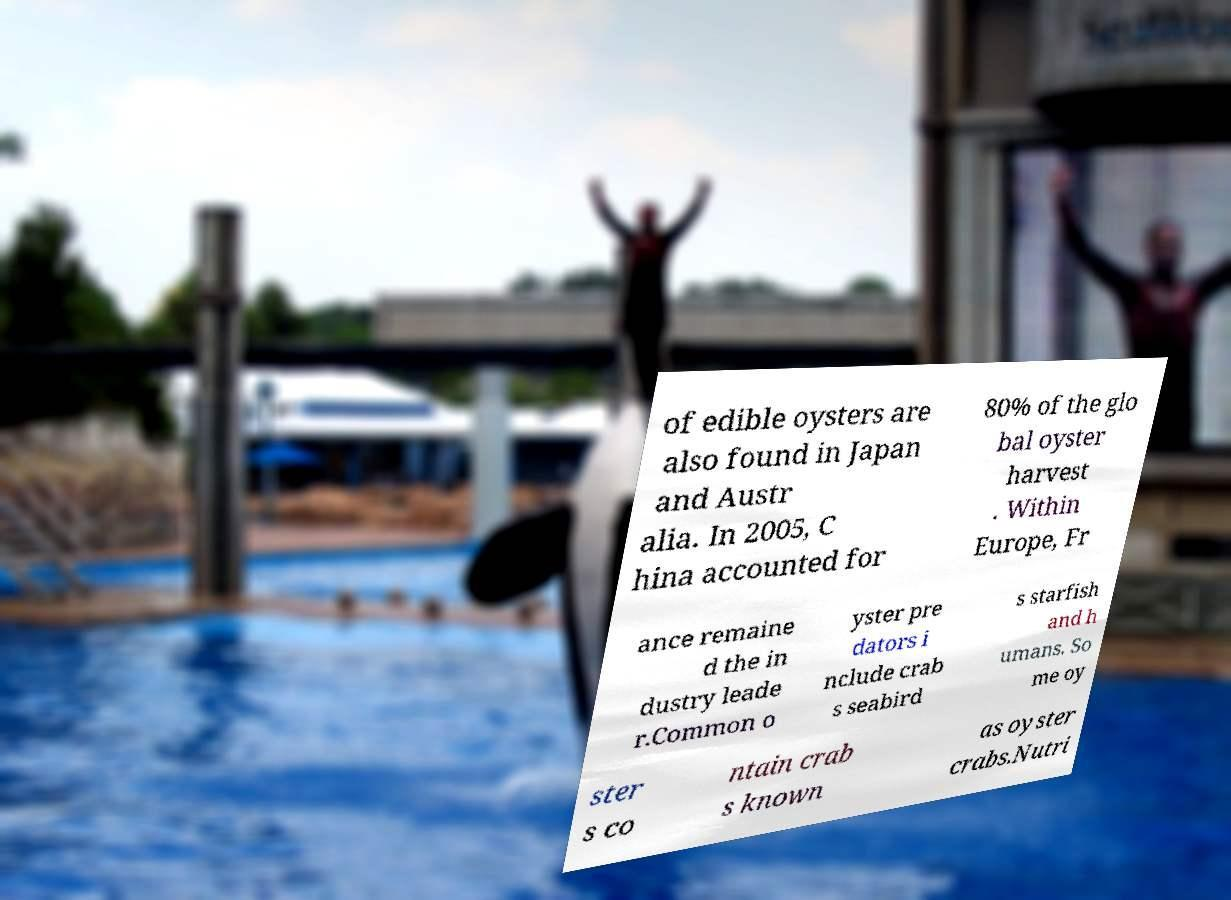Can you accurately transcribe the text from the provided image for me? of edible oysters are also found in Japan and Austr alia. In 2005, C hina accounted for 80% of the glo bal oyster harvest . Within Europe, Fr ance remaine d the in dustry leade r.Common o yster pre dators i nclude crab s seabird s starfish and h umans. So me oy ster s co ntain crab s known as oyster crabs.Nutri 